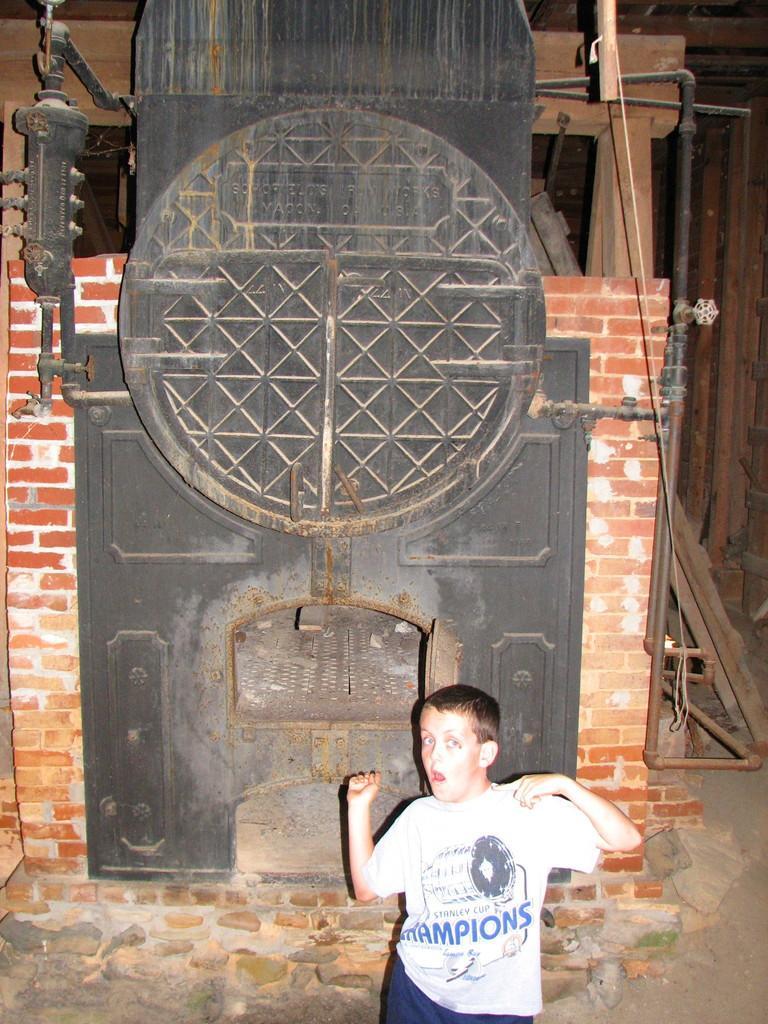Could you give a brief overview of what you see in this image? This is an inside view. At the bottom of this image I can see a boy wearing white color t-shirt, standing and giving pose for the picture. At the back of this boy I can see a machine which is made up of metal and it is used to forging. Beside this I can see a wall. In the background there are some wood materials. 